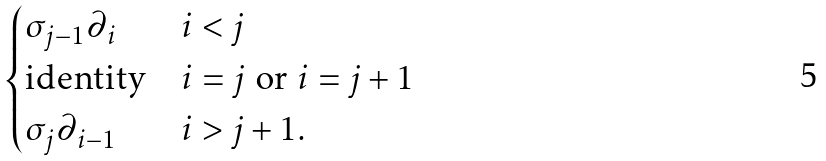<formula> <loc_0><loc_0><loc_500><loc_500>\begin{cases} \sigma _ { j - 1 } \partial _ { i } & \text {$i<j$} \\ \text {identity} & \text {$i=j$ or $i=j+1$} \\ \sigma _ { j } \partial _ { i - 1 } & \text {$i>j+1$} . \end{cases}</formula> 